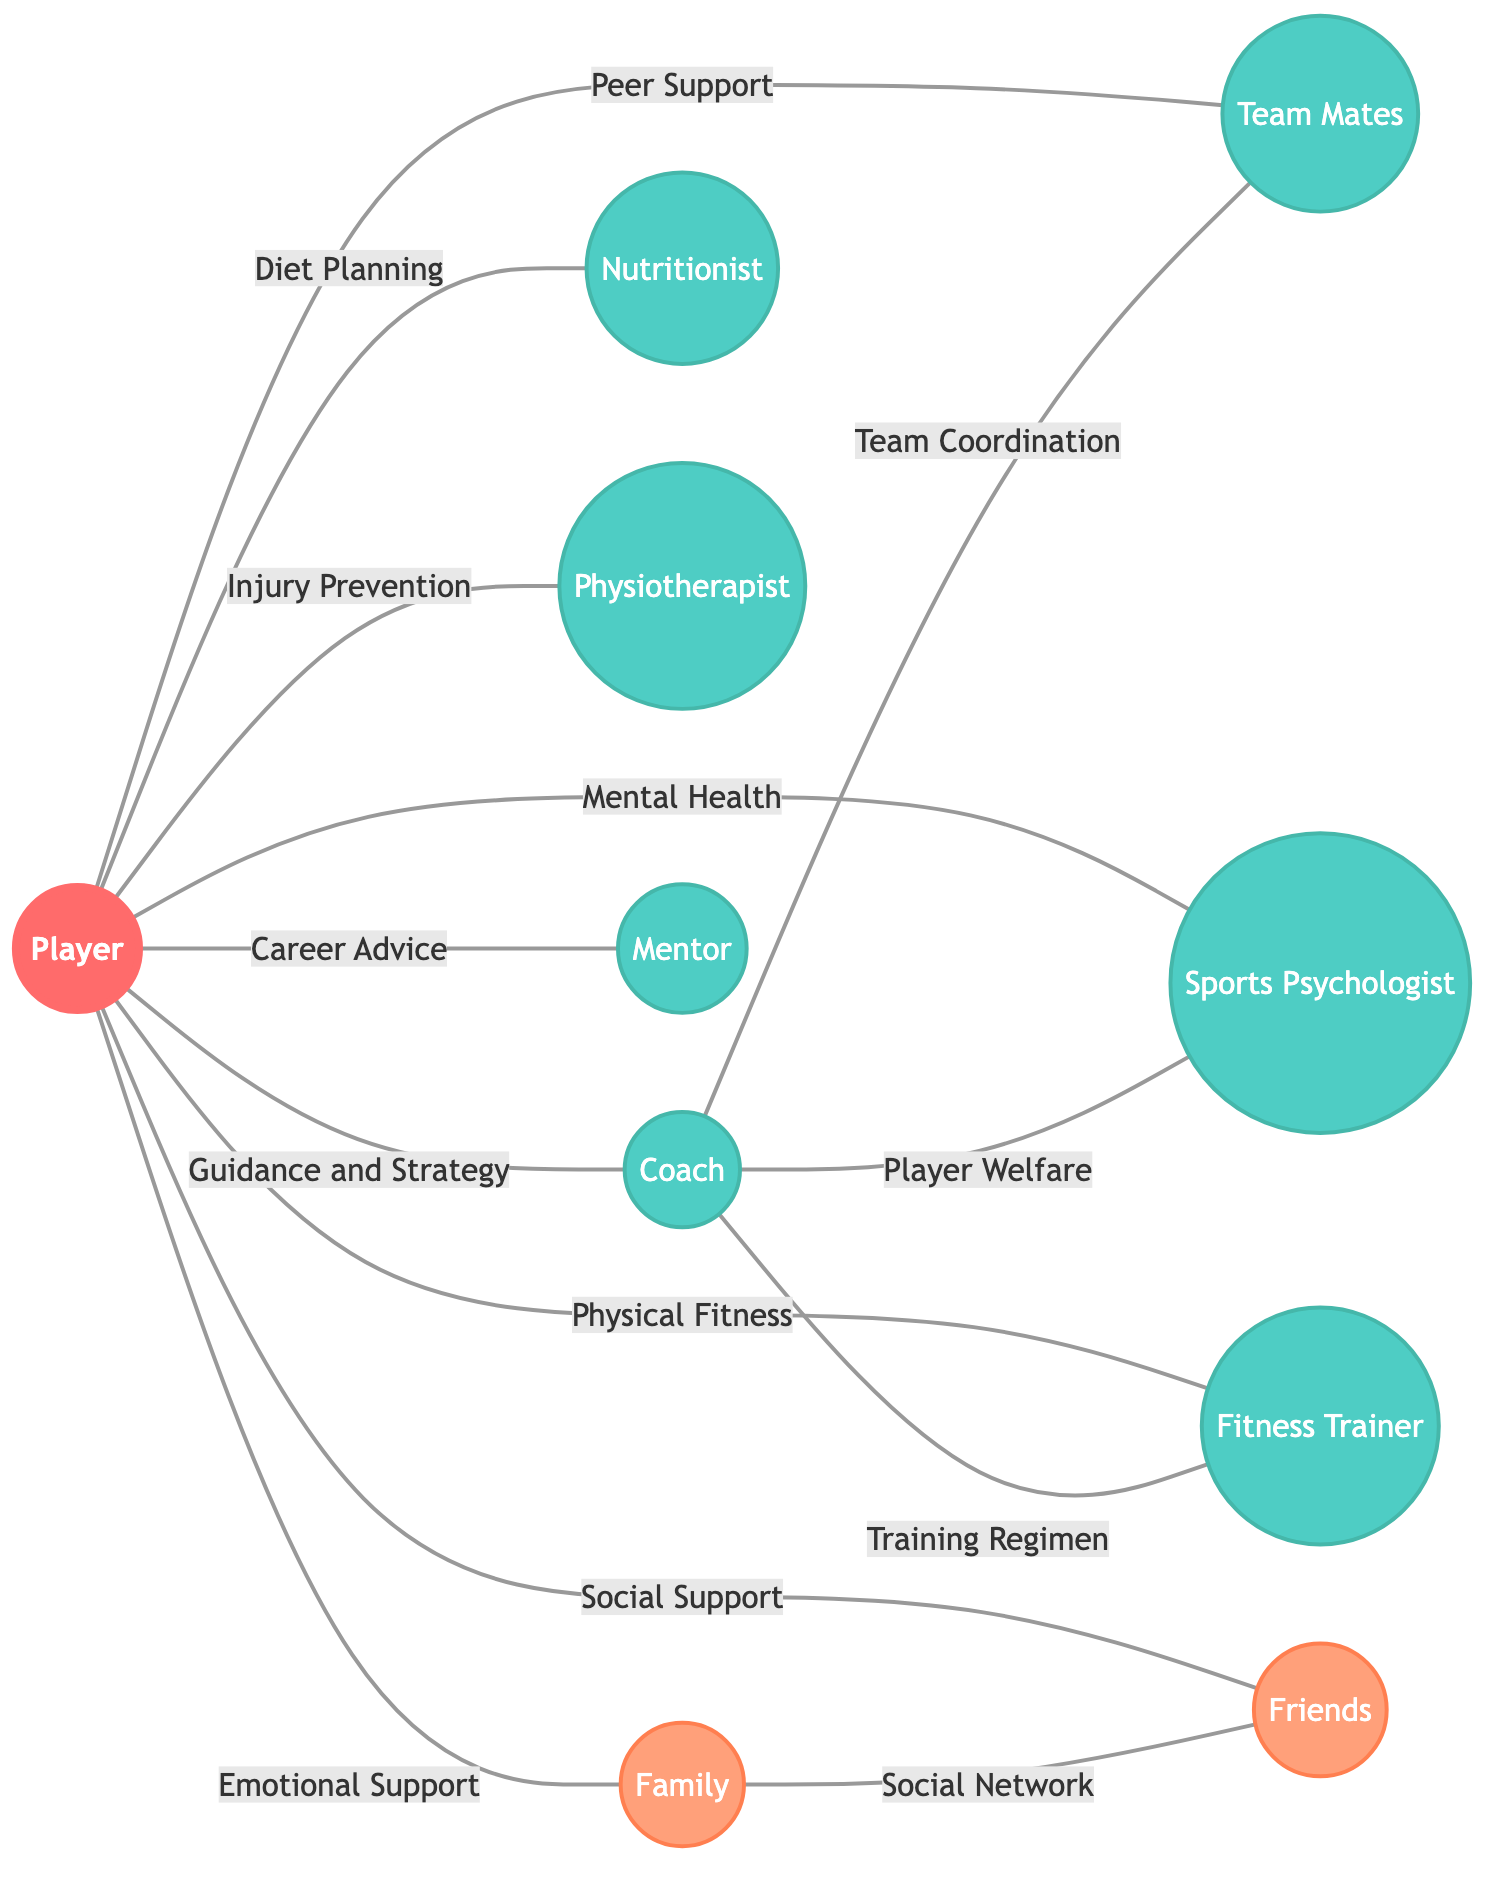What are the nodes in this undirected graph? The nodes in the graph represent key roles in a support system for the player, which includes Player, Coach, Team Mates, Sports Psychologist, Nutritionist, Physiotherapist, Fitness Trainer, Family, Friends, and Mentor.
Answer: Player, Coach, Team Mates, Sports Psychologist, Nutritionist, Physiotherapist, Fitness Trainer, Family, Friends, Mentor How many edges are connected to the Player? To find the number of edges connected to the Player, we can count the relationships in the graph that connect from Player to other nodes. There are 9 edges connected to Player, each representing different types of support.
Answer: 9 What type of support does the Player receive from the Nutritionist? The edge connecting Player to Nutritionist is labeled 'Diet Planning', indicating that this is the type of support provided.
Answer: Diet Planning Who coordinates with the Team Mates? The edge that connects Coach to Team Mates is labeled 'Team Coordination', meaning the coach is responsible for coordinating with the team mates.
Answer: Coach How many categories of support can be identified in the diagram? The nodes and edges can be grouped into three categories: professional support (like Coach, Sports Psychologist, Nutritionist), physical support (like Physiotherapist, Fitness Trainer), and emotional/social support (like Family, Friends, Mentor). Counting these categories gives us three distinct groups.
Answer: 3 What is the relationship between Coach and Fitness Trainer? The edge connecting Coach and Fitness Trainer is labeled 'Training Regimen', indicating that the Coach oversees or coordinates the training activities with the Fitness Trainer.
Answer: Training Regimen Which node provides emotional support to the Player? The edge from Player to Family is labeled 'Emotional Support', showing that the Family offers this specific type of support to the Player.
Answer: Family Which two nodes are connected by the label 'Player Welfare'? The edge labeled 'Player Welfare' connects Coach and Sports Psychologist, indicating the relationship between these two roles focused on the player's well-being.
Answer: Coach, Sports Psychologist How many nodes provide social support to the Player? The Player is connected to two nodes providing social support: Family and Friends. Counting these nodes gives us two sources of social support for the Player, which can be considered essential for a well-rounded support system.
Answer: 2 What is the purpose of the connection between Family and Friends? The edge connecting Family to Friends is labeled 'Social Network', indicating that this relationship pertains to the social interactions and connections between these two groups, which may support the Player indirectly.
Answer: Social Network 